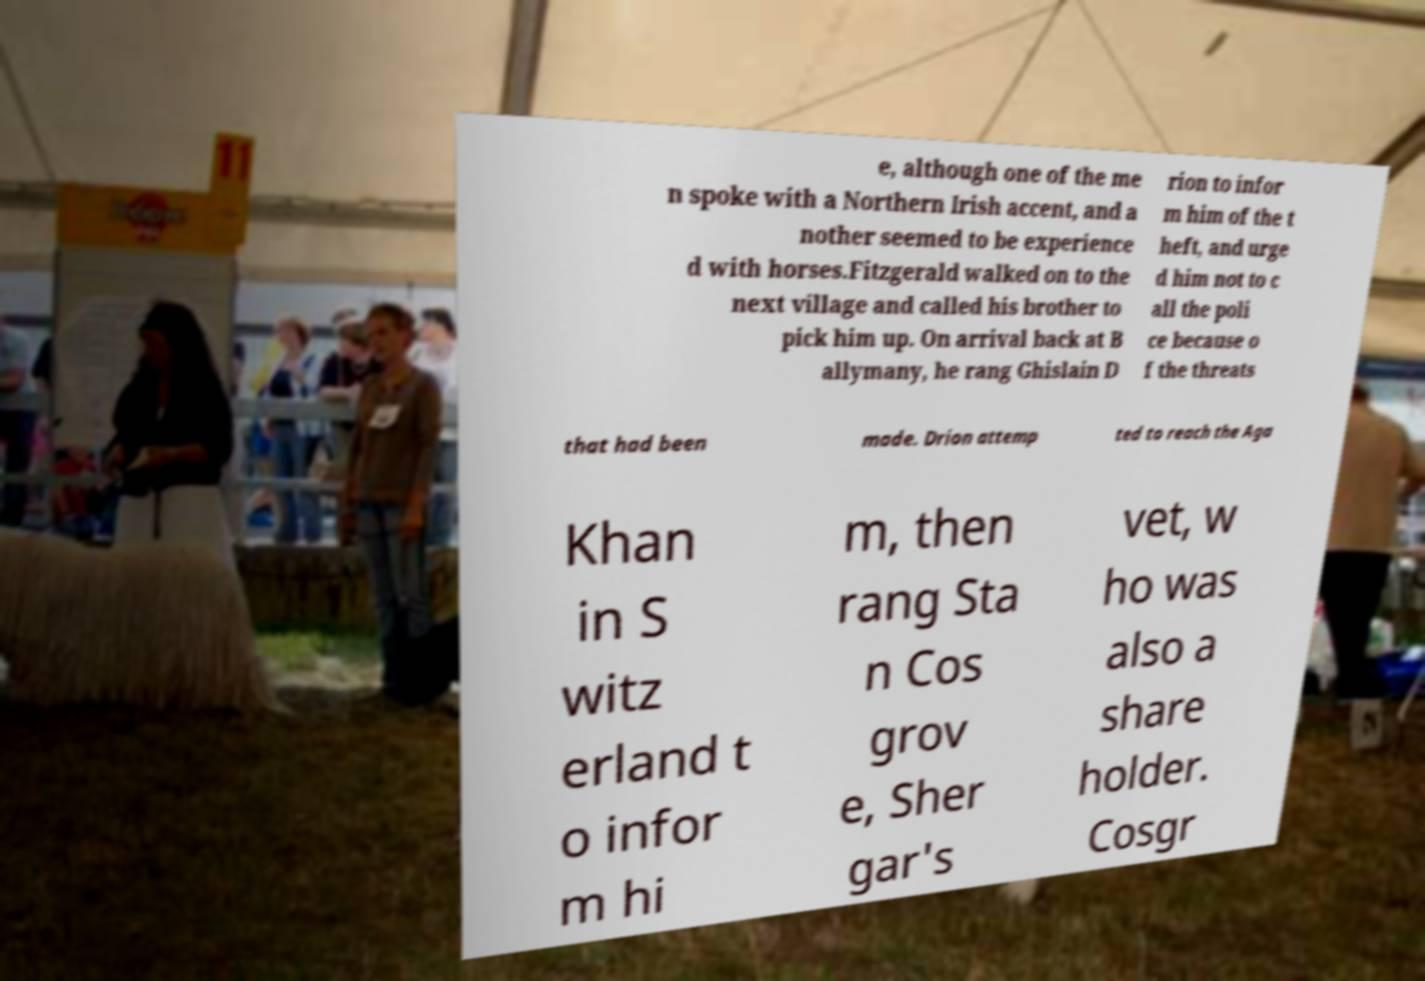Can you accurately transcribe the text from the provided image for me? e, although one of the me n spoke with a Northern Irish accent, and a nother seemed to be experience d with horses.Fitzgerald walked on to the next village and called his brother to pick him up. On arrival back at B allymany, he rang Ghislain D rion to infor m him of the t heft, and urge d him not to c all the poli ce because o f the threats that had been made. Drion attemp ted to reach the Aga Khan in S witz erland t o infor m hi m, then rang Sta n Cos grov e, Sher gar's vet, w ho was also a share holder. Cosgr 